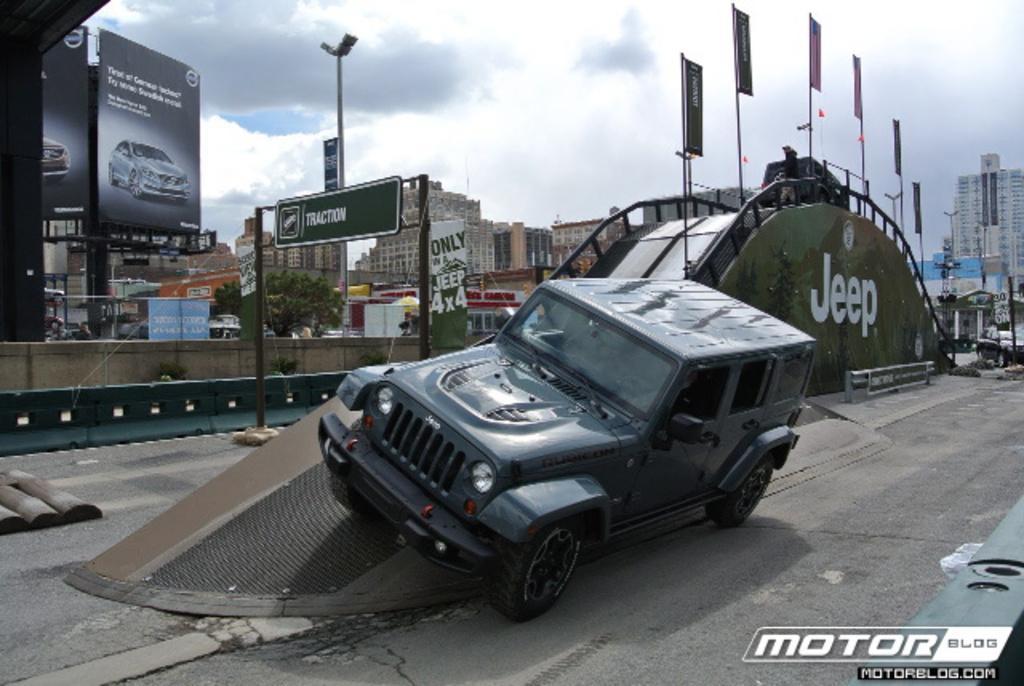Please provide a concise description of this image. In this image we can see a cloudy sky. There is a tree, a vehicle and few advertising boards in the image. There is a road and many buildings in the image. 